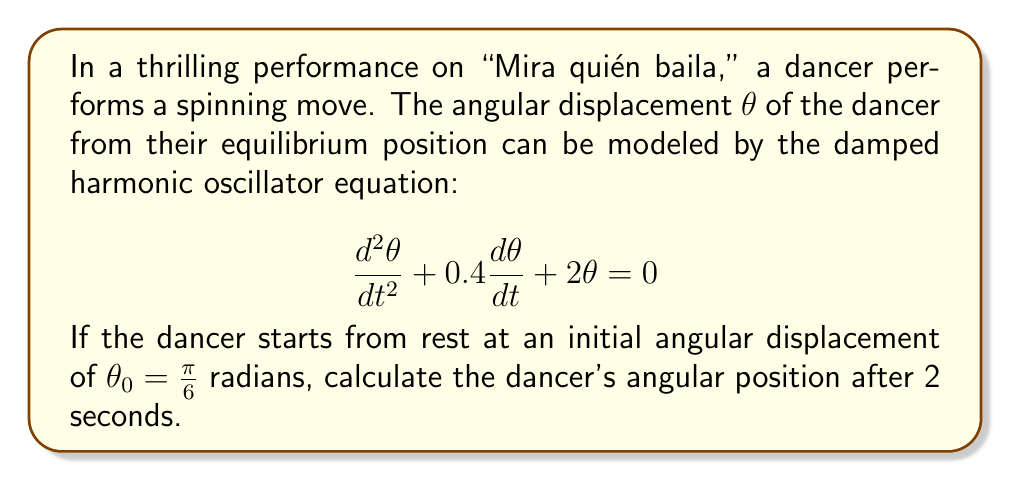Can you answer this question? To solve this problem, we need to follow these steps:

1) The general form of a damped harmonic oscillator equation is:
   $$\frac{d^2\theta}{dt^2} + 2\beta\frac{d\theta}{dt} + \omega_0^2\theta = 0$$
   where $\beta$ is the damping coefficient and $\omega_0$ is the natural frequency.

2) Comparing our equation to the general form, we see that $2\beta = 0.4$ and $\omega_0^2 = 2$.

3) Calculate $\beta$ and $\omega_0$:
   $\beta = 0.2$ and $\omega_0 = \sqrt{2}$

4) To determine the type of damping, we calculate $\beta^2 - \omega_0^2$:
   $0.2^2 - 2 = -1.96 < 0$, so this is an underdamped system.

5) For underdamped systems, the solution has the form:
   $$\theta(t) = Ae^{-\beta t}\cos(\omega t - \phi)$$
   where $\omega = \sqrt{\omega_0^2 - \beta^2} = \sqrt{2 - 0.04} = \sqrt{1.96}$

6) Given the initial conditions $\theta(0) = \frac{\pi}{6}$ and $\frac{d\theta}{dt}(0) = 0$, we can determine $A$ and $\phi$:
   $A = \frac{\pi}{6}$ and $\phi = 0$

7) Therefore, our solution is:
   $$\theta(t) = \frac{\pi}{6}e^{-0.2t}\cos(\sqrt{1.96}t)$$

8) To find $\theta(2)$, we substitute $t = 2$:
   $$\theta(2) = \frac{\pi}{6}e^{-0.4}\cos(2\sqrt{1.96})$$

9) Evaluating this expression:
   $$\theta(2) \approx 0.1374 \text{ radians}$$
Answer: $\theta(2) \approx 0.1374 \text{ radians}$ 